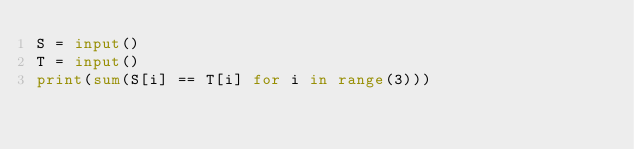Convert code to text. <code><loc_0><loc_0><loc_500><loc_500><_Python_>S = input()
T = input()
print(sum(S[i] == T[i] for i in range(3)))</code> 